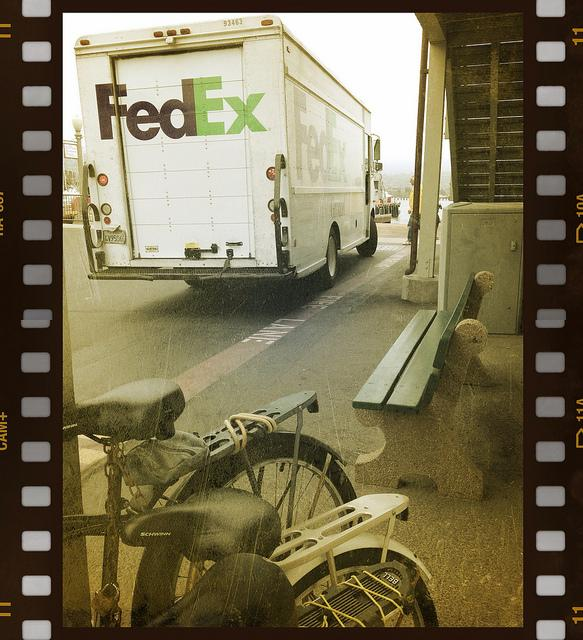What type of business is the truck for? Please explain your reasoning. delivering packages. The brand is famous for delivering packages. 